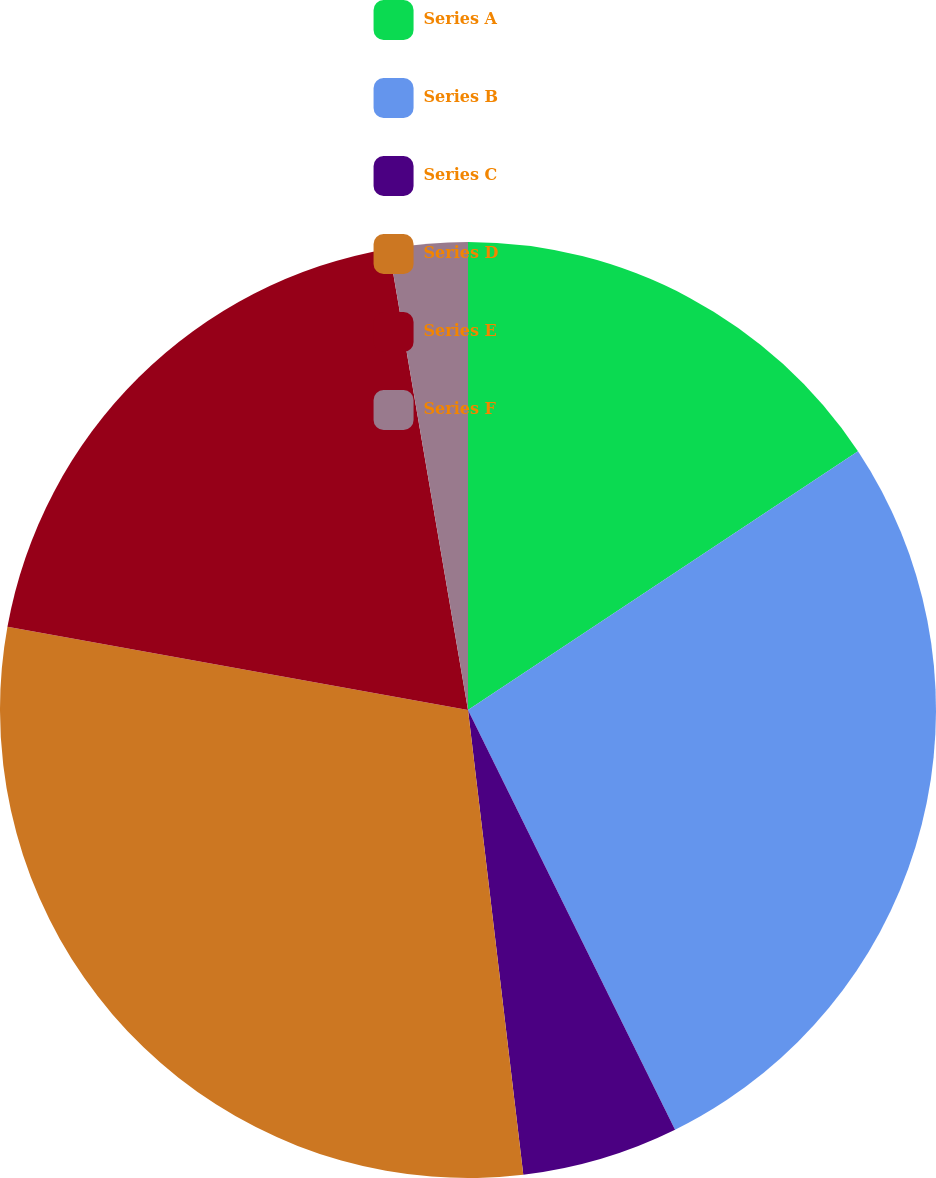Convert chart. <chart><loc_0><loc_0><loc_500><loc_500><pie_chart><fcel>Series A<fcel>Series B<fcel>Series C<fcel>Series D<fcel>Series E<fcel>Series F<nl><fcel>15.68%<fcel>27.03%<fcel>5.41%<fcel>29.73%<fcel>19.46%<fcel>2.7%<nl></chart> 